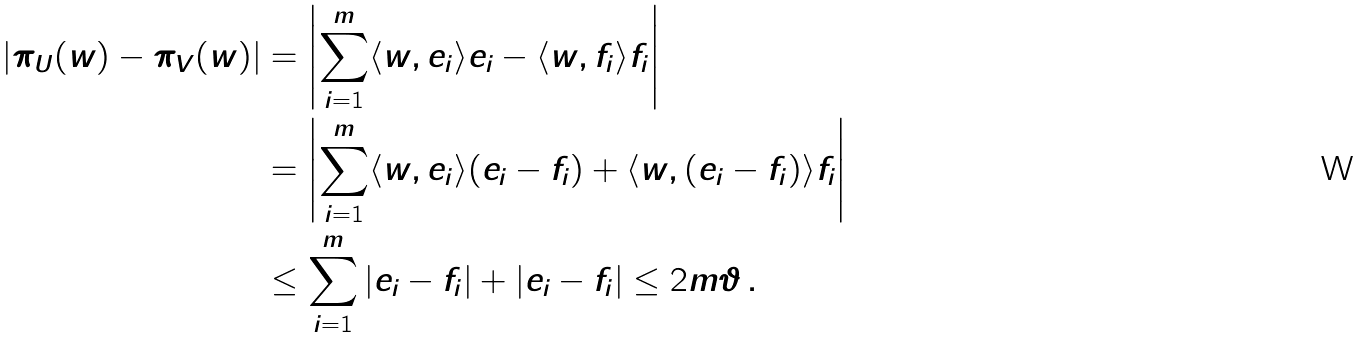<formula> <loc_0><loc_0><loc_500><loc_500>| \pi _ { U } ( w ) - \pi _ { V } ( w ) | & = \left | \sum _ { i = 1 } ^ { m } \langle w , e _ { i } \rangle e _ { i } - \langle w , f _ { i } \rangle f _ { i } \right | \\ & = \left | \sum _ { i = 1 } ^ { m } \langle w , e _ { i } \rangle ( e _ { i } - f _ { i } ) + \langle w , ( e _ { i } - f _ { i } ) \rangle f _ { i } \right | \\ & \leq \sum _ { i = 1 } ^ { m } | e _ { i } - f _ { i } | + | e _ { i } - f _ { i } | \leq 2 m \vartheta \, .</formula> 